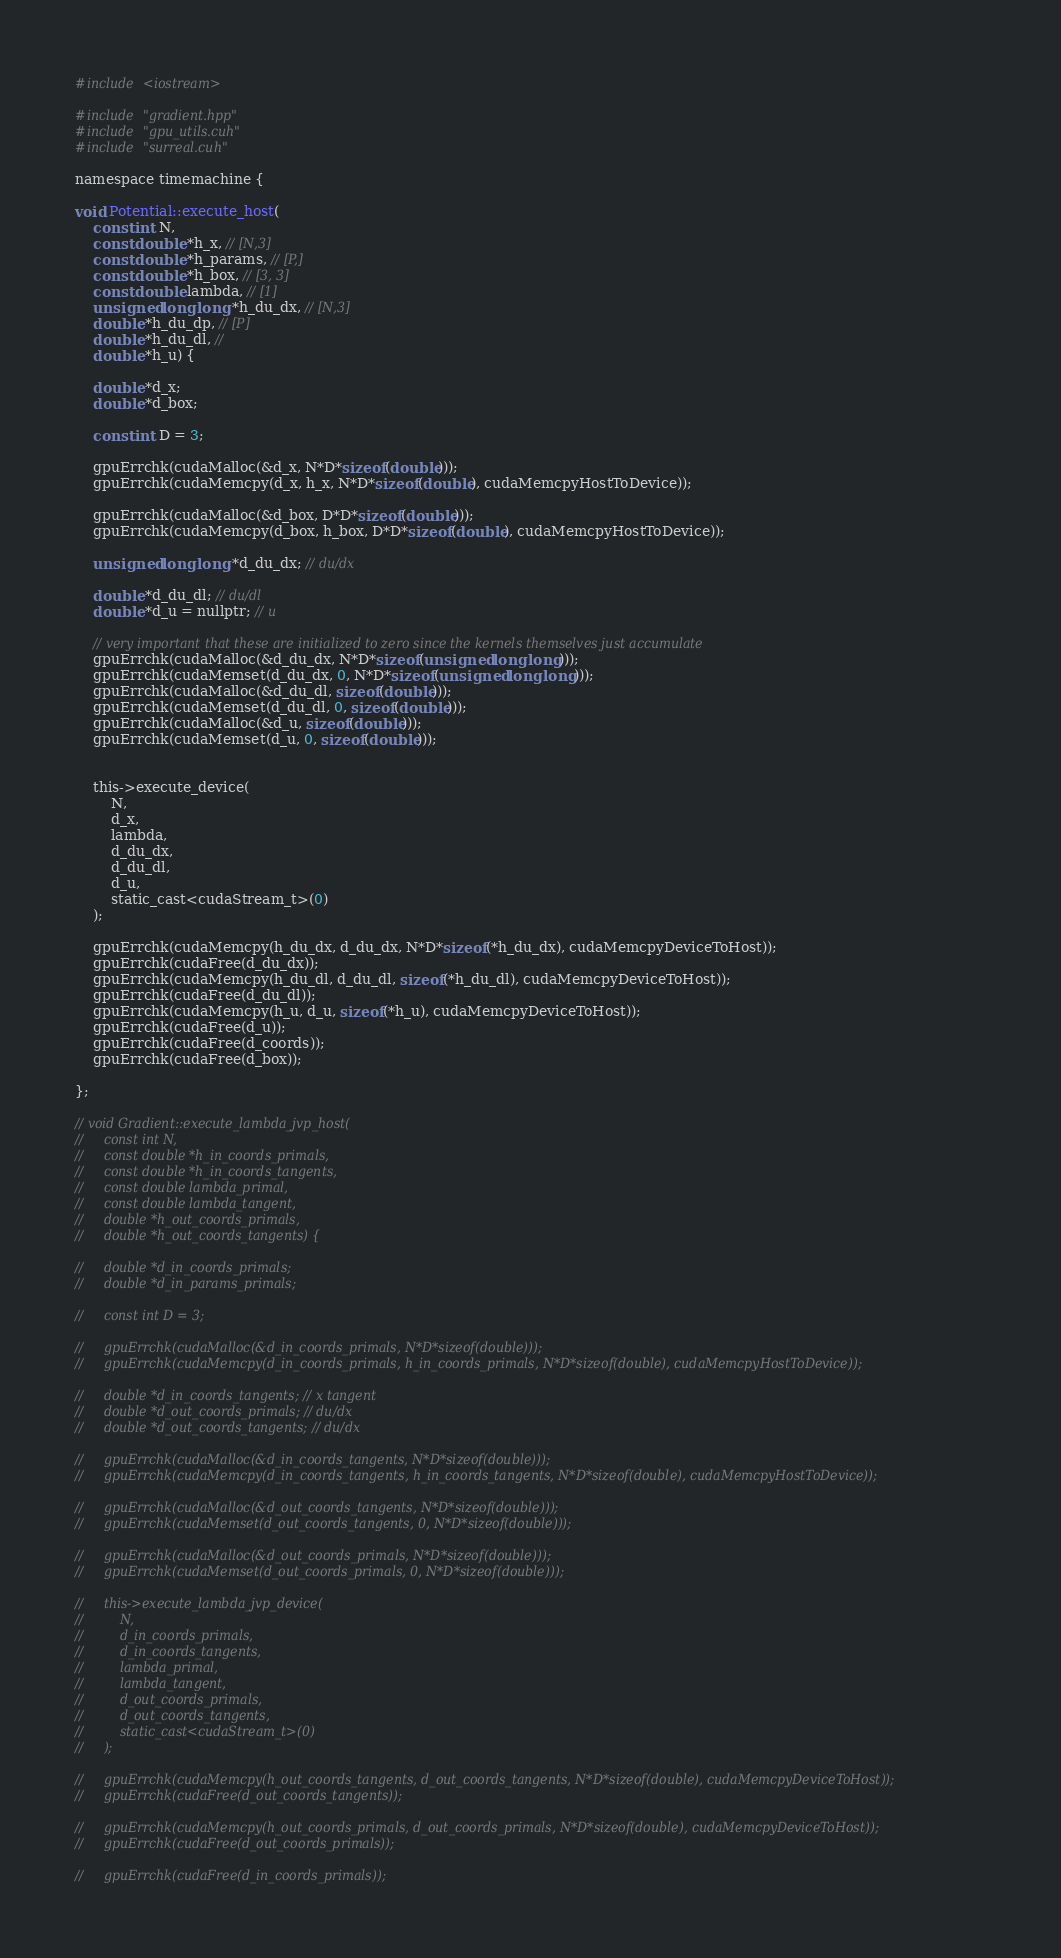<code> <loc_0><loc_0><loc_500><loc_500><_Cuda_>
#include <iostream>

#include "gradient.hpp"
#include "gpu_utils.cuh"
#include "surreal.cuh"

namespace timemachine {

void Potential::execute_host(
    const int N,
    const double *h_x, // [N,3]
    const double *h_params, // [P,]
    const double *h_box, // [3, 3]
    const double lambda, // [1]
    unsigned long long *h_du_dx, // [N,3]
    double *h_du_dp, // [P]
    double *h_du_dl, //
    double *h_u) {

    double *d_x;
    double *d_box;

    const int D = 3;

    gpuErrchk(cudaMalloc(&d_x, N*D*sizeof(double)));
    gpuErrchk(cudaMemcpy(d_x, h_x, N*D*sizeof(double), cudaMemcpyHostToDevice));

    gpuErrchk(cudaMalloc(&d_box, D*D*sizeof(double)));
    gpuErrchk(cudaMemcpy(d_box, h_box, D*D*sizeof(double), cudaMemcpyHostToDevice));

    unsigned long long *d_du_dx; // du/dx

    double *d_du_dl; // du/dl
    double *d_u = nullptr; // u

    // very important that these are initialized to zero since the kernels themselves just accumulate
    gpuErrchk(cudaMalloc(&d_du_dx, N*D*sizeof(unsigned long long)));
    gpuErrchk(cudaMemset(d_du_dx, 0, N*D*sizeof(unsigned long long)));
    gpuErrchk(cudaMalloc(&d_du_dl, sizeof(double)));
    gpuErrchk(cudaMemset(d_du_dl, 0, sizeof(double)));
    gpuErrchk(cudaMalloc(&d_u, sizeof(double)));
    gpuErrchk(cudaMemset(d_u, 0, sizeof(double)));


    this->execute_device(
        N,
        d_x, 
        lambda,
        d_du_dx,
        d_du_dl,
        d_u,
        static_cast<cudaStream_t>(0)
    );

    gpuErrchk(cudaMemcpy(h_du_dx, d_du_dx, N*D*sizeof(*h_du_dx), cudaMemcpyDeviceToHost));
    gpuErrchk(cudaFree(d_du_dx));
    gpuErrchk(cudaMemcpy(h_du_dl, d_du_dl, sizeof(*h_du_dl), cudaMemcpyDeviceToHost));
    gpuErrchk(cudaFree(d_du_dl));
    gpuErrchk(cudaMemcpy(h_u, d_u, sizeof(*h_u), cudaMemcpyDeviceToHost));
    gpuErrchk(cudaFree(d_u));
    gpuErrchk(cudaFree(d_coords));
    gpuErrchk(cudaFree(d_box));

};

// void Gradient::execute_lambda_jvp_host(
//     const int N,
//     const double *h_in_coords_primals,
//     const double *h_in_coords_tangents,
//     const double lambda_primal,
//     const double lambda_tangent,
//     double *h_out_coords_primals,
//     double *h_out_coords_tangents) {

//     double *d_in_coords_primals;
//     double *d_in_params_primals;

//     const int D = 3;

//     gpuErrchk(cudaMalloc(&d_in_coords_primals, N*D*sizeof(double)));
//     gpuErrchk(cudaMemcpy(d_in_coords_primals, h_in_coords_primals, N*D*sizeof(double), cudaMemcpyHostToDevice));

//     double *d_in_coords_tangents; // x tangent
//     double *d_out_coords_primals; // du/dx
//     double *d_out_coords_tangents; // du/dx

//     gpuErrchk(cudaMalloc(&d_in_coords_tangents, N*D*sizeof(double)));
//     gpuErrchk(cudaMemcpy(d_in_coords_tangents, h_in_coords_tangents, N*D*sizeof(double), cudaMemcpyHostToDevice));

//     gpuErrchk(cudaMalloc(&d_out_coords_tangents, N*D*sizeof(double)));
//     gpuErrchk(cudaMemset(d_out_coords_tangents, 0, N*D*sizeof(double)));

//     gpuErrchk(cudaMalloc(&d_out_coords_primals, N*D*sizeof(double)));
//     gpuErrchk(cudaMemset(d_out_coords_primals, 0, N*D*sizeof(double)));

//     this->execute_lambda_jvp_device(
//         N,
//         d_in_coords_primals, 
//         d_in_coords_tangents,
//         lambda_primal,
//         lambda_tangent,
//         d_out_coords_primals,
//         d_out_coords_tangents,
//         static_cast<cudaStream_t>(0)
//     );

//     gpuErrchk(cudaMemcpy(h_out_coords_tangents, d_out_coords_tangents, N*D*sizeof(double), cudaMemcpyDeviceToHost));
//     gpuErrchk(cudaFree(d_out_coords_tangents));

//     gpuErrchk(cudaMemcpy(h_out_coords_primals, d_out_coords_primals, N*D*sizeof(double), cudaMemcpyDeviceToHost));
//     gpuErrchk(cudaFree(d_out_coords_primals));

//     gpuErrchk(cudaFree(d_in_coords_primals));</code> 